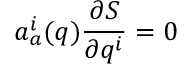Convert formula to latex. <formula><loc_0><loc_0><loc_500><loc_500>a _ { a } ^ { i } ( q ) \frac { \partial S } { \partial q ^ { i } } = 0</formula> 